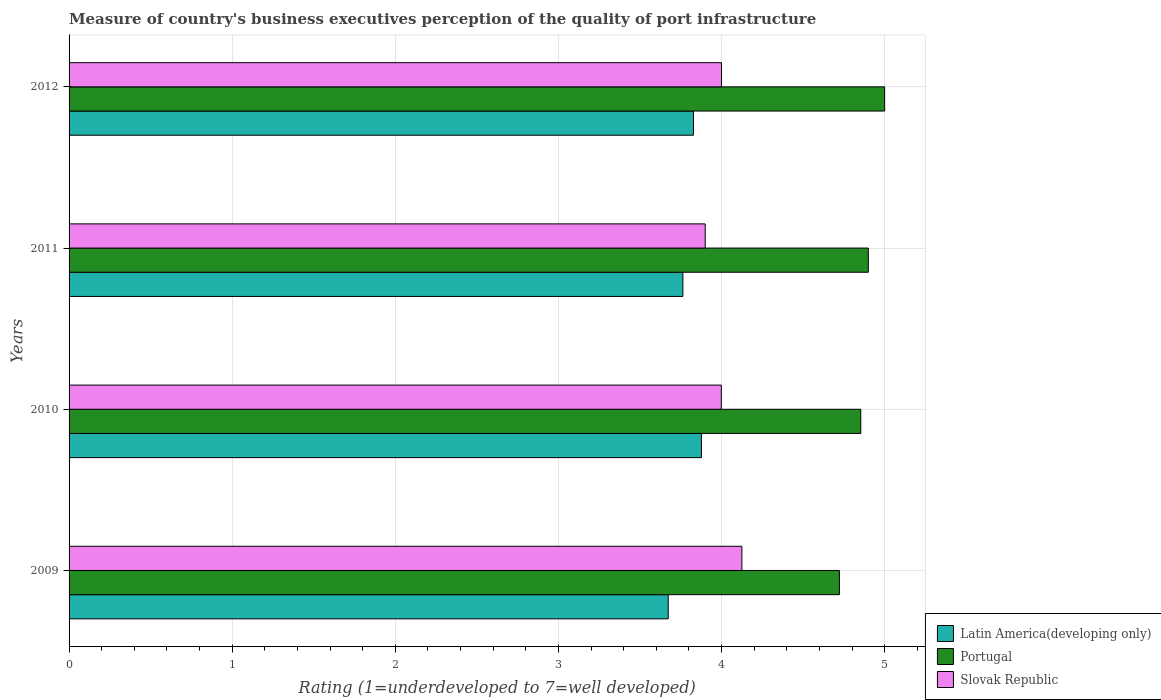How many different coloured bars are there?
Provide a short and direct response. 3. How many groups of bars are there?
Give a very brief answer. 4. Are the number of bars on each tick of the Y-axis equal?
Your answer should be very brief. Yes. How many bars are there on the 3rd tick from the top?
Offer a very short reply. 3. How many bars are there on the 4th tick from the bottom?
Give a very brief answer. 3. What is the label of the 2nd group of bars from the top?
Your response must be concise. 2011. Across all years, what is the maximum ratings of the quality of port infrastructure in Slovak Republic?
Your response must be concise. 4.12. Across all years, what is the minimum ratings of the quality of port infrastructure in Portugal?
Give a very brief answer. 4.72. In which year was the ratings of the quality of port infrastructure in Slovak Republic minimum?
Offer a terse response. 2011. What is the total ratings of the quality of port infrastructure in Portugal in the graph?
Offer a terse response. 19.48. What is the difference between the ratings of the quality of port infrastructure in Latin America(developing only) in 2009 and that in 2012?
Offer a terse response. -0.15. What is the difference between the ratings of the quality of port infrastructure in Portugal in 2009 and the ratings of the quality of port infrastructure in Slovak Republic in 2012?
Your answer should be compact. 0.72. What is the average ratings of the quality of port infrastructure in Slovak Republic per year?
Make the answer very short. 4.01. In the year 2010, what is the difference between the ratings of the quality of port infrastructure in Portugal and ratings of the quality of port infrastructure in Slovak Republic?
Your answer should be very brief. 0.85. What is the ratio of the ratings of the quality of port infrastructure in Slovak Republic in 2009 to that in 2012?
Ensure brevity in your answer.  1.03. Is the ratings of the quality of port infrastructure in Latin America(developing only) in 2011 less than that in 2012?
Your response must be concise. Yes. What is the difference between the highest and the second highest ratings of the quality of port infrastructure in Slovak Republic?
Provide a succinct answer. 0.12. What is the difference between the highest and the lowest ratings of the quality of port infrastructure in Slovak Republic?
Your answer should be compact. 0.22. In how many years, is the ratings of the quality of port infrastructure in Portugal greater than the average ratings of the quality of port infrastructure in Portugal taken over all years?
Make the answer very short. 2. What does the 1st bar from the top in 2011 represents?
Your response must be concise. Slovak Republic. What does the 1st bar from the bottom in 2010 represents?
Your answer should be compact. Latin America(developing only). How many bars are there?
Offer a very short reply. 12. Are the values on the major ticks of X-axis written in scientific E-notation?
Give a very brief answer. No. Does the graph contain any zero values?
Your answer should be very brief. No. Where does the legend appear in the graph?
Your answer should be very brief. Bottom right. How many legend labels are there?
Your answer should be very brief. 3. How are the legend labels stacked?
Your response must be concise. Vertical. What is the title of the graph?
Offer a terse response. Measure of country's business executives perception of the quality of port infrastructure. What is the label or title of the X-axis?
Your answer should be very brief. Rating (1=underdeveloped to 7=well developed). What is the label or title of the Y-axis?
Ensure brevity in your answer.  Years. What is the Rating (1=underdeveloped to 7=well developed) in Latin America(developing only) in 2009?
Provide a short and direct response. 3.67. What is the Rating (1=underdeveloped to 7=well developed) of Portugal in 2009?
Provide a short and direct response. 4.72. What is the Rating (1=underdeveloped to 7=well developed) of Slovak Republic in 2009?
Your response must be concise. 4.12. What is the Rating (1=underdeveloped to 7=well developed) of Latin America(developing only) in 2010?
Give a very brief answer. 3.88. What is the Rating (1=underdeveloped to 7=well developed) in Portugal in 2010?
Your answer should be very brief. 4.85. What is the Rating (1=underdeveloped to 7=well developed) in Slovak Republic in 2010?
Your response must be concise. 4. What is the Rating (1=underdeveloped to 7=well developed) in Latin America(developing only) in 2011?
Provide a succinct answer. 3.76. What is the Rating (1=underdeveloped to 7=well developed) of Portugal in 2011?
Your answer should be compact. 4.9. What is the Rating (1=underdeveloped to 7=well developed) of Latin America(developing only) in 2012?
Ensure brevity in your answer.  3.83. What is the Rating (1=underdeveloped to 7=well developed) in Portugal in 2012?
Provide a succinct answer. 5. Across all years, what is the maximum Rating (1=underdeveloped to 7=well developed) of Latin America(developing only)?
Offer a very short reply. 3.88. Across all years, what is the maximum Rating (1=underdeveloped to 7=well developed) of Slovak Republic?
Offer a terse response. 4.12. Across all years, what is the minimum Rating (1=underdeveloped to 7=well developed) of Latin America(developing only)?
Make the answer very short. 3.67. Across all years, what is the minimum Rating (1=underdeveloped to 7=well developed) in Portugal?
Provide a short and direct response. 4.72. What is the total Rating (1=underdeveloped to 7=well developed) of Latin America(developing only) in the graph?
Provide a succinct answer. 15.14. What is the total Rating (1=underdeveloped to 7=well developed) in Portugal in the graph?
Provide a short and direct response. 19.48. What is the total Rating (1=underdeveloped to 7=well developed) in Slovak Republic in the graph?
Give a very brief answer. 16.02. What is the difference between the Rating (1=underdeveloped to 7=well developed) in Latin America(developing only) in 2009 and that in 2010?
Ensure brevity in your answer.  -0.2. What is the difference between the Rating (1=underdeveloped to 7=well developed) in Portugal in 2009 and that in 2010?
Provide a succinct answer. -0.13. What is the difference between the Rating (1=underdeveloped to 7=well developed) of Slovak Republic in 2009 and that in 2010?
Provide a succinct answer. 0.13. What is the difference between the Rating (1=underdeveloped to 7=well developed) in Latin America(developing only) in 2009 and that in 2011?
Give a very brief answer. -0.09. What is the difference between the Rating (1=underdeveloped to 7=well developed) of Portugal in 2009 and that in 2011?
Provide a short and direct response. -0.18. What is the difference between the Rating (1=underdeveloped to 7=well developed) in Slovak Republic in 2009 and that in 2011?
Your answer should be compact. 0.22. What is the difference between the Rating (1=underdeveloped to 7=well developed) of Latin America(developing only) in 2009 and that in 2012?
Your response must be concise. -0.15. What is the difference between the Rating (1=underdeveloped to 7=well developed) of Portugal in 2009 and that in 2012?
Keep it short and to the point. -0.28. What is the difference between the Rating (1=underdeveloped to 7=well developed) in Slovak Republic in 2009 and that in 2012?
Ensure brevity in your answer.  0.12. What is the difference between the Rating (1=underdeveloped to 7=well developed) of Latin America(developing only) in 2010 and that in 2011?
Give a very brief answer. 0.11. What is the difference between the Rating (1=underdeveloped to 7=well developed) in Portugal in 2010 and that in 2011?
Provide a short and direct response. -0.05. What is the difference between the Rating (1=underdeveloped to 7=well developed) in Slovak Republic in 2010 and that in 2011?
Ensure brevity in your answer.  0.1. What is the difference between the Rating (1=underdeveloped to 7=well developed) in Latin America(developing only) in 2010 and that in 2012?
Ensure brevity in your answer.  0.05. What is the difference between the Rating (1=underdeveloped to 7=well developed) of Portugal in 2010 and that in 2012?
Make the answer very short. -0.15. What is the difference between the Rating (1=underdeveloped to 7=well developed) in Slovak Republic in 2010 and that in 2012?
Provide a succinct answer. -0. What is the difference between the Rating (1=underdeveloped to 7=well developed) in Latin America(developing only) in 2011 and that in 2012?
Provide a short and direct response. -0.06. What is the difference between the Rating (1=underdeveloped to 7=well developed) in Slovak Republic in 2011 and that in 2012?
Give a very brief answer. -0.1. What is the difference between the Rating (1=underdeveloped to 7=well developed) of Latin America(developing only) in 2009 and the Rating (1=underdeveloped to 7=well developed) of Portugal in 2010?
Ensure brevity in your answer.  -1.18. What is the difference between the Rating (1=underdeveloped to 7=well developed) in Latin America(developing only) in 2009 and the Rating (1=underdeveloped to 7=well developed) in Slovak Republic in 2010?
Make the answer very short. -0.33. What is the difference between the Rating (1=underdeveloped to 7=well developed) of Portugal in 2009 and the Rating (1=underdeveloped to 7=well developed) of Slovak Republic in 2010?
Ensure brevity in your answer.  0.72. What is the difference between the Rating (1=underdeveloped to 7=well developed) of Latin America(developing only) in 2009 and the Rating (1=underdeveloped to 7=well developed) of Portugal in 2011?
Offer a very short reply. -1.23. What is the difference between the Rating (1=underdeveloped to 7=well developed) in Latin America(developing only) in 2009 and the Rating (1=underdeveloped to 7=well developed) in Slovak Republic in 2011?
Your answer should be very brief. -0.23. What is the difference between the Rating (1=underdeveloped to 7=well developed) of Portugal in 2009 and the Rating (1=underdeveloped to 7=well developed) of Slovak Republic in 2011?
Your answer should be compact. 0.82. What is the difference between the Rating (1=underdeveloped to 7=well developed) of Latin America(developing only) in 2009 and the Rating (1=underdeveloped to 7=well developed) of Portugal in 2012?
Give a very brief answer. -1.33. What is the difference between the Rating (1=underdeveloped to 7=well developed) in Latin America(developing only) in 2009 and the Rating (1=underdeveloped to 7=well developed) in Slovak Republic in 2012?
Offer a very short reply. -0.33. What is the difference between the Rating (1=underdeveloped to 7=well developed) of Portugal in 2009 and the Rating (1=underdeveloped to 7=well developed) of Slovak Republic in 2012?
Provide a succinct answer. 0.72. What is the difference between the Rating (1=underdeveloped to 7=well developed) of Latin America(developing only) in 2010 and the Rating (1=underdeveloped to 7=well developed) of Portugal in 2011?
Offer a very short reply. -1.02. What is the difference between the Rating (1=underdeveloped to 7=well developed) of Latin America(developing only) in 2010 and the Rating (1=underdeveloped to 7=well developed) of Slovak Republic in 2011?
Make the answer very short. -0.02. What is the difference between the Rating (1=underdeveloped to 7=well developed) in Portugal in 2010 and the Rating (1=underdeveloped to 7=well developed) in Slovak Republic in 2011?
Your answer should be compact. 0.95. What is the difference between the Rating (1=underdeveloped to 7=well developed) in Latin America(developing only) in 2010 and the Rating (1=underdeveloped to 7=well developed) in Portugal in 2012?
Your response must be concise. -1.12. What is the difference between the Rating (1=underdeveloped to 7=well developed) in Latin America(developing only) in 2010 and the Rating (1=underdeveloped to 7=well developed) in Slovak Republic in 2012?
Provide a short and direct response. -0.12. What is the difference between the Rating (1=underdeveloped to 7=well developed) in Portugal in 2010 and the Rating (1=underdeveloped to 7=well developed) in Slovak Republic in 2012?
Offer a terse response. 0.85. What is the difference between the Rating (1=underdeveloped to 7=well developed) of Latin America(developing only) in 2011 and the Rating (1=underdeveloped to 7=well developed) of Portugal in 2012?
Your answer should be very brief. -1.24. What is the difference between the Rating (1=underdeveloped to 7=well developed) in Latin America(developing only) in 2011 and the Rating (1=underdeveloped to 7=well developed) in Slovak Republic in 2012?
Offer a very short reply. -0.24. What is the difference between the Rating (1=underdeveloped to 7=well developed) in Portugal in 2011 and the Rating (1=underdeveloped to 7=well developed) in Slovak Republic in 2012?
Give a very brief answer. 0.9. What is the average Rating (1=underdeveloped to 7=well developed) of Latin America(developing only) per year?
Provide a short and direct response. 3.79. What is the average Rating (1=underdeveloped to 7=well developed) of Portugal per year?
Make the answer very short. 4.87. What is the average Rating (1=underdeveloped to 7=well developed) in Slovak Republic per year?
Your response must be concise. 4.01. In the year 2009, what is the difference between the Rating (1=underdeveloped to 7=well developed) of Latin America(developing only) and Rating (1=underdeveloped to 7=well developed) of Portugal?
Keep it short and to the point. -1.05. In the year 2009, what is the difference between the Rating (1=underdeveloped to 7=well developed) of Latin America(developing only) and Rating (1=underdeveloped to 7=well developed) of Slovak Republic?
Your answer should be very brief. -0.45. In the year 2009, what is the difference between the Rating (1=underdeveloped to 7=well developed) of Portugal and Rating (1=underdeveloped to 7=well developed) of Slovak Republic?
Your response must be concise. 0.6. In the year 2010, what is the difference between the Rating (1=underdeveloped to 7=well developed) of Latin America(developing only) and Rating (1=underdeveloped to 7=well developed) of Portugal?
Offer a very short reply. -0.98. In the year 2010, what is the difference between the Rating (1=underdeveloped to 7=well developed) in Latin America(developing only) and Rating (1=underdeveloped to 7=well developed) in Slovak Republic?
Make the answer very short. -0.12. In the year 2010, what is the difference between the Rating (1=underdeveloped to 7=well developed) in Portugal and Rating (1=underdeveloped to 7=well developed) in Slovak Republic?
Provide a short and direct response. 0.85. In the year 2011, what is the difference between the Rating (1=underdeveloped to 7=well developed) in Latin America(developing only) and Rating (1=underdeveloped to 7=well developed) in Portugal?
Make the answer very short. -1.14. In the year 2011, what is the difference between the Rating (1=underdeveloped to 7=well developed) in Latin America(developing only) and Rating (1=underdeveloped to 7=well developed) in Slovak Republic?
Your response must be concise. -0.14. In the year 2012, what is the difference between the Rating (1=underdeveloped to 7=well developed) in Latin America(developing only) and Rating (1=underdeveloped to 7=well developed) in Portugal?
Your answer should be very brief. -1.17. In the year 2012, what is the difference between the Rating (1=underdeveloped to 7=well developed) of Latin America(developing only) and Rating (1=underdeveloped to 7=well developed) of Slovak Republic?
Provide a short and direct response. -0.17. In the year 2012, what is the difference between the Rating (1=underdeveloped to 7=well developed) in Portugal and Rating (1=underdeveloped to 7=well developed) in Slovak Republic?
Your answer should be very brief. 1. What is the ratio of the Rating (1=underdeveloped to 7=well developed) in Latin America(developing only) in 2009 to that in 2010?
Offer a very short reply. 0.95. What is the ratio of the Rating (1=underdeveloped to 7=well developed) in Portugal in 2009 to that in 2010?
Your answer should be compact. 0.97. What is the ratio of the Rating (1=underdeveloped to 7=well developed) of Slovak Republic in 2009 to that in 2010?
Provide a succinct answer. 1.03. What is the ratio of the Rating (1=underdeveloped to 7=well developed) of Latin America(developing only) in 2009 to that in 2011?
Ensure brevity in your answer.  0.98. What is the ratio of the Rating (1=underdeveloped to 7=well developed) of Portugal in 2009 to that in 2011?
Keep it short and to the point. 0.96. What is the ratio of the Rating (1=underdeveloped to 7=well developed) of Slovak Republic in 2009 to that in 2011?
Provide a succinct answer. 1.06. What is the ratio of the Rating (1=underdeveloped to 7=well developed) in Latin America(developing only) in 2009 to that in 2012?
Your answer should be compact. 0.96. What is the ratio of the Rating (1=underdeveloped to 7=well developed) of Portugal in 2009 to that in 2012?
Give a very brief answer. 0.94. What is the ratio of the Rating (1=underdeveloped to 7=well developed) in Slovak Republic in 2009 to that in 2012?
Provide a short and direct response. 1.03. What is the ratio of the Rating (1=underdeveloped to 7=well developed) of Latin America(developing only) in 2010 to that in 2011?
Your response must be concise. 1.03. What is the ratio of the Rating (1=underdeveloped to 7=well developed) of Portugal in 2010 to that in 2011?
Your answer should be compact. 0.99. What is the ratio of the Rating (1=underdeveloped to 7=well developed) of Slovak Republic in 2010 to that in 2011?
Your answer should be compact. 1.03. What is the ratio of the Rating (1=underdeveloped to 7=well developed) in Latin America(developing only) in 2010 to that in 2012?
Provide a short and direct response. 1.01. What is the ratio of the Rating (1=underdeveloped to 7=well developed) of Portugal in 2010 to that in 2012?
Offer a terse response. 0.97. What is the ratio of the Rating (1=underdeveloped to 7=well developed) of Slovak Republic in 2010 to that in 2012?
Make the answer very short. 1. What is the ratio of the Rating (1=underdeveloped to 7=well developed) in Latin America(developing only) in 2011 to that in 2012?
Provide a short and direct response. 0.98. What is the difference between the highest and the second highest Rating (1=underdeveloped to 7=well developed) of Latin America(developing only)?
Offer a terse response. 0.05. What is the difference between the highest and the second highest Rating (1=underdeveloped to 7=well developed) of Portugal?
Your answer should be very brief. 0.1. What is the difference between the highest and the second highest Rating (1=underdeveloped to 7=well developed) in Slovak Republic?
Your answer should be very brief. 0.12. What is the difference between the highest and the lowest Rating (1=underdeveloped to 7=well developed) in Latin America(developing only)?
Your response must be concise. 0.2. What is the difference between the highest and the lowest Rating (1=underdeveloped to 7=well developed) of Portugal?
Keep it short and to the point. 0.28. What is the difference between the highest and the lowest Rating (1=underdeveloped to 7=well developed) in Slovak Republic?
Your response must be concise. 0.22. 